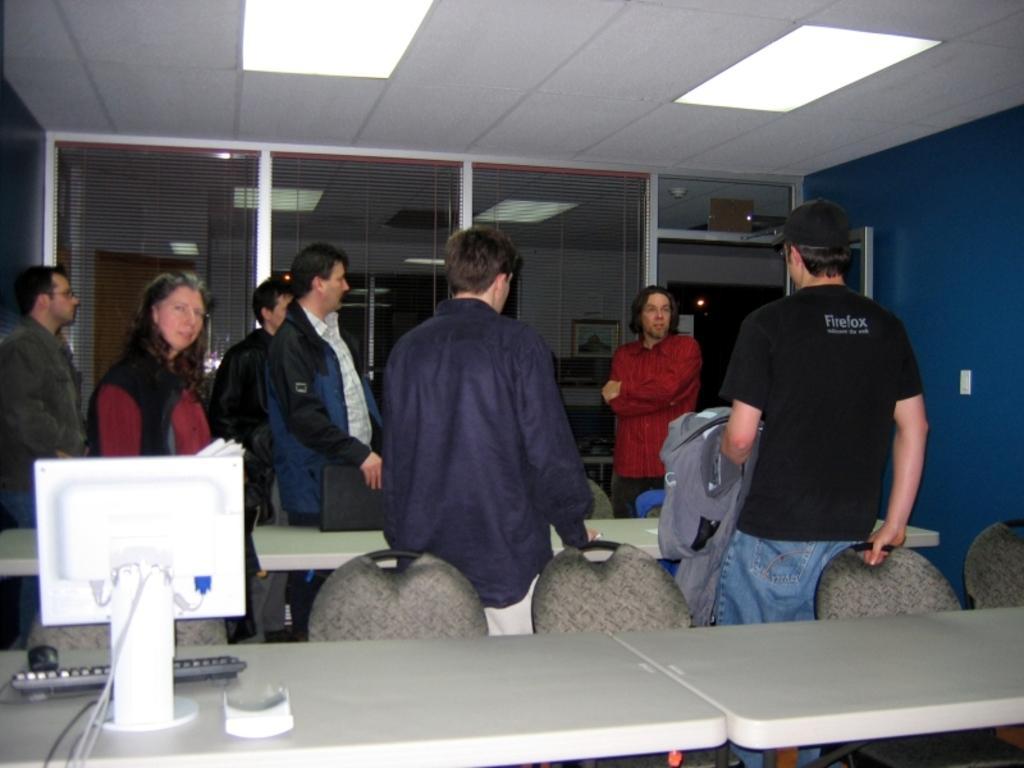Please provide a concise description of this image. The image looks like it is clicked inside the office. There are seven persons in this image. One lady and six men. In the front there is a table on which there is a computer along with keyboard and mouse. To the left the man standing is wearing a gray color jacket. To the right the man standing is wearing a black t-shirt and blue jeans and holding a jacket. In the background there is a glass partition. To the top there is a roof with lights. 